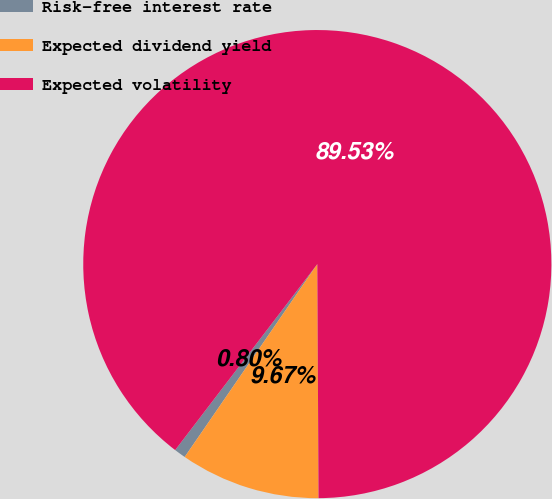<chart> <loc_0><loc_0><loc_500><loc_500><pie_chart><fcel>Risk-free interest rate<fcel>Expected dividend yield<fcel>Expected volatility<nl><fcel>0.8%<fcel>9.67%<fcel>89.53%<nl></chart> 